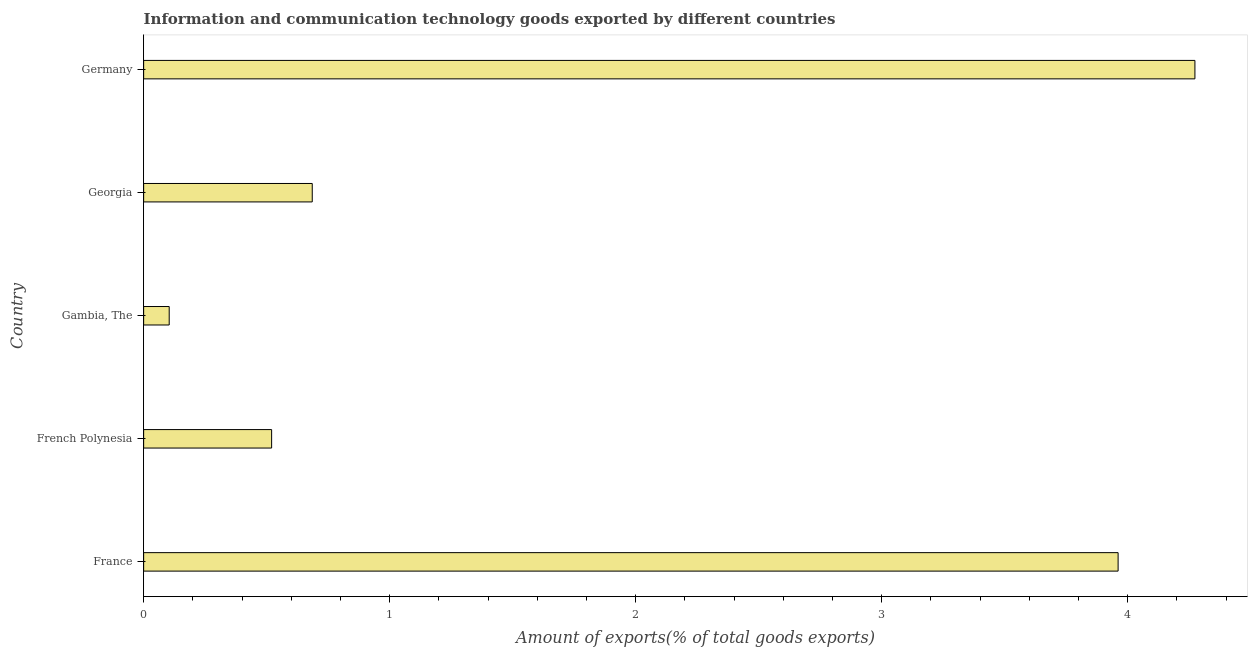Does the graph contain any zero values?
Provide a succinct answer. No. What is the title of the graph?
Offer a very short reply. Information and communication technology goods exported by different countries. What is the label or title of the X-axis?
Your answer should be compact. Amount of exports(% of total goods exports). What is the amount of ict goods exports in Georgia?
Offer a very short reply. 0.69. Across all countries, what is the maximum amount of ict goods exports?
Offer a terse response. 4.27. Across all countries, what is the minimum amount of ict goods exports?
Provide a succinct answer. 0.1. In which country was the amount of ict goods exports minimum?
Provide a short and direct response. Gambia, The. What is the sum of the amount of ict goods exports?
Give a very brief answer. 9.54. What is the difference between the amount of ict goods exports in France and Germany?
Provide a short and direct response. -0.31. What is the average amount of ict goods exports per country?
Provide a short and direct response. 1.91. What is the median amount of ict goods exports?
Your answer should be compact. 0.69. What is the ratio of the amount of ict goods exports in French Polynesia to that in Germany?
Your answer should be compact. 0.12. What is the difference between the highest and the second highest amount of ict goods exports?
Give a very brief answer. 0.31. Is the sum of the amount of ict goods exports in French Polynesia and Georgia greater than the maximum amount of ict goods exports across all countries?
Your response must be concise. No. What is the difference between the highest and the lowest amount of ict goods exports?
Offer a very short reply. 4.17. In how many countries, is the amount of ict goods exports greater than the average amount of ict goods exports taken over all countries?
Offer a very short reply. 2. Are all the bars in the graph horizontal?
Make the answer very short. Yes. How many countries are there in the graph?
Offer a terse response. 5. Are the values on the major ticks of X-axis written in scientific E-notation?
Offer a terse response. No. What is the Amount of exports(% of total goods exports) in France?
Provide a short and direct response. 3.96. What is the Amount of exports(% of total goods exports) of French Polynesia?
Offer a terse response. 0.52. What is the Amount of exports(% of total goods exports) of Gambia, The?
Your answer should be very brief. 0.1. What is the Amount of exports(% of total goods exports) in Georgia?
Ensure brevity in your answer.  0.69. What is the Amount of exports(% of total goods exports) of Germany?
Provide a succinct answer. 4.27. What is the difference between the Amount of exports(% of total goods exports) in France and French Polynesia?
Ensure brevity in your answer.  3.44. What is the difference between the Amount of exports(% of total goods exports) in France and Gambia, The?
Provide a succinct answer. 3.86. What is the difference between the Amount of exports(% of total goods exports) in France and Georgia?
Your response must be concise. 3.28. What is the difference between the Amount of exports(% of total goods exports) in France and Germany?
Provide a short and direct response. -0.31. What is the difference between the Amount of exports(% of total goods exports) in French Polynesia and Gambia, The?
Keep it short and to the point. 0.42. What is the difference between the Amount of exports(% of total goods exports) in French Polynesia and Georgia?
Offer a terse response. -0.17. What is the difference between the Amount of exports(% of total goods exports) in French Polynesia and Germany?
Your answer should be very brief. -3.75. What is the difference between the Amount of exports(% of total goods exports) in Gambia, The and Georgia?
Your answer should be very brief. -0.58. What is the difference between the Amount of exports(% of total goods exports) in Gambia, The and Germany?
Ensure brevity in your answer.  -4.17. What is the difference between the Amount of exports(% of total goods exports) in Georgia and Germany?
Keep it short and to the point. -3.59. What is the ratio of the Amount of exports(% of total goods exports) in France to that in French Polynesia?
Give a very brief answer. 7.61. What is the ratio of the Amount of exports(% of total goods exports) in France to that in Gambia, The?
Your answer should be very brief. 38.13. What is the ratio of the Amount of exports(% of total goods exports) in France to that in Georgia?
Your response must be concise. 5.78. What is the ratio of the Amount of exports(% of total goods exports) in France to that in Germany?
Provide a short and direct response. 0.93. What is the ratio of the Amount of exports(% of total goods exports) in French Polynesia to that in Gambia, The?
Keep it short and to the point. 5.01. What is the ratio of the Amount of exports(% of total goods exports) in French Polynesia to that in Georgia?
Your response must be concise. 0.76. What is the ratio of the Amount of exports(% of total goods exports) in French Polynesia to that in Germany?
Ensure brevity in your answer.  0.12. What is the ratio of the Amount of exports(% of total goods exports) in Gambia, The to that in Georgia?
Your answer should be very brief. 0.15. What is the ratio of the Amount of exports(% of total goods exports) in Gambia, The to that in Germany?
Your answer should be compact. 0.02. What is the ratio of the Amount of exports(% of total goods exports) in Georgia to that in Germany?
Make the answer very short. 0.16. 